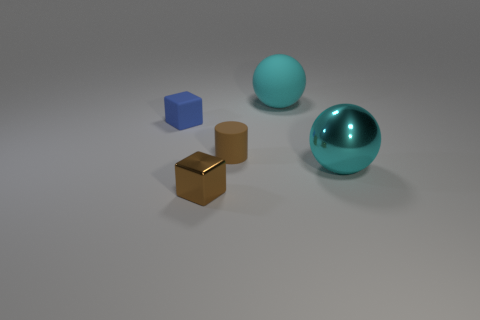Add 2 tiny brown metal blocks. How many objects exist? 7 Subtract all cylinders. How many objects are left? 4 Add 2 cyan rubber objects. How many cyan rubber objects are left? 3 Add 4 small purple balls. How many small purple balls exist? 4 Subtract 0 blue cylinders. How many objects are left? 5 Subtract all purple spheres. Subtract all brown matte things. How many objects are left? 4 